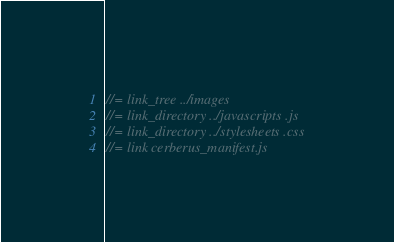Convert code to text. <code><loc_0><loc_0><loc_500><loc_500><_JavaScript_>
//= link_tree ../images
//= link_directory ../javascripts .js
//= link_directory ../stylesheets .css
//= link cerberus_manifest.js
</code> 